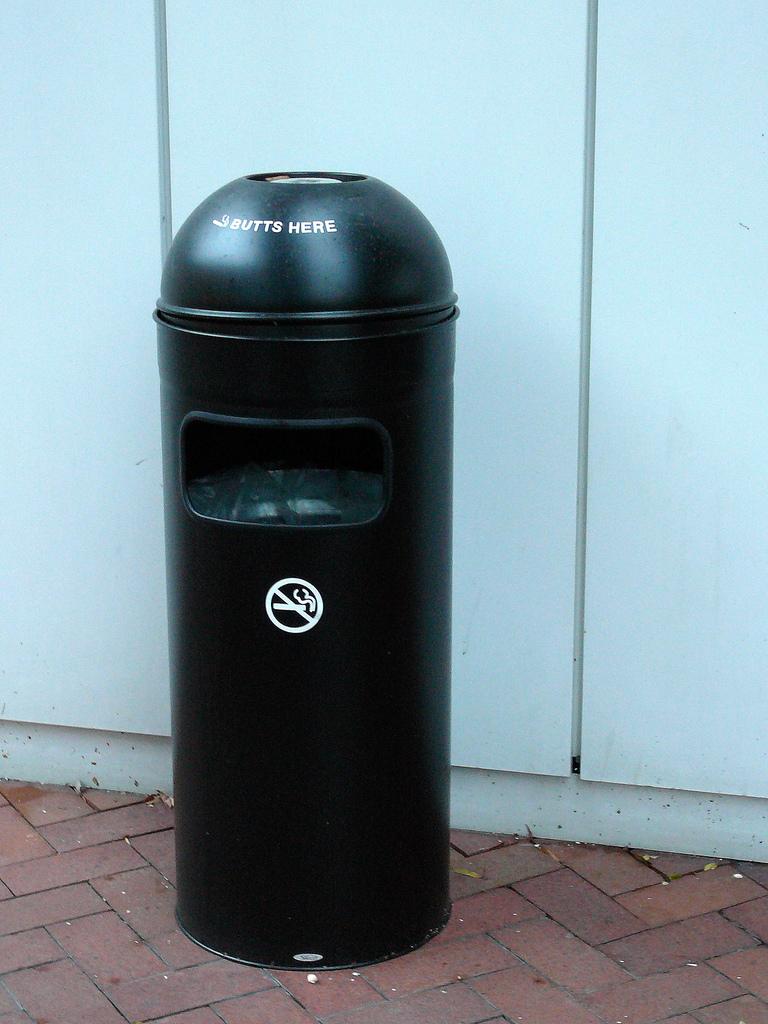What goes in this trash can?
Ensure brevity in your answer.  Butts. 